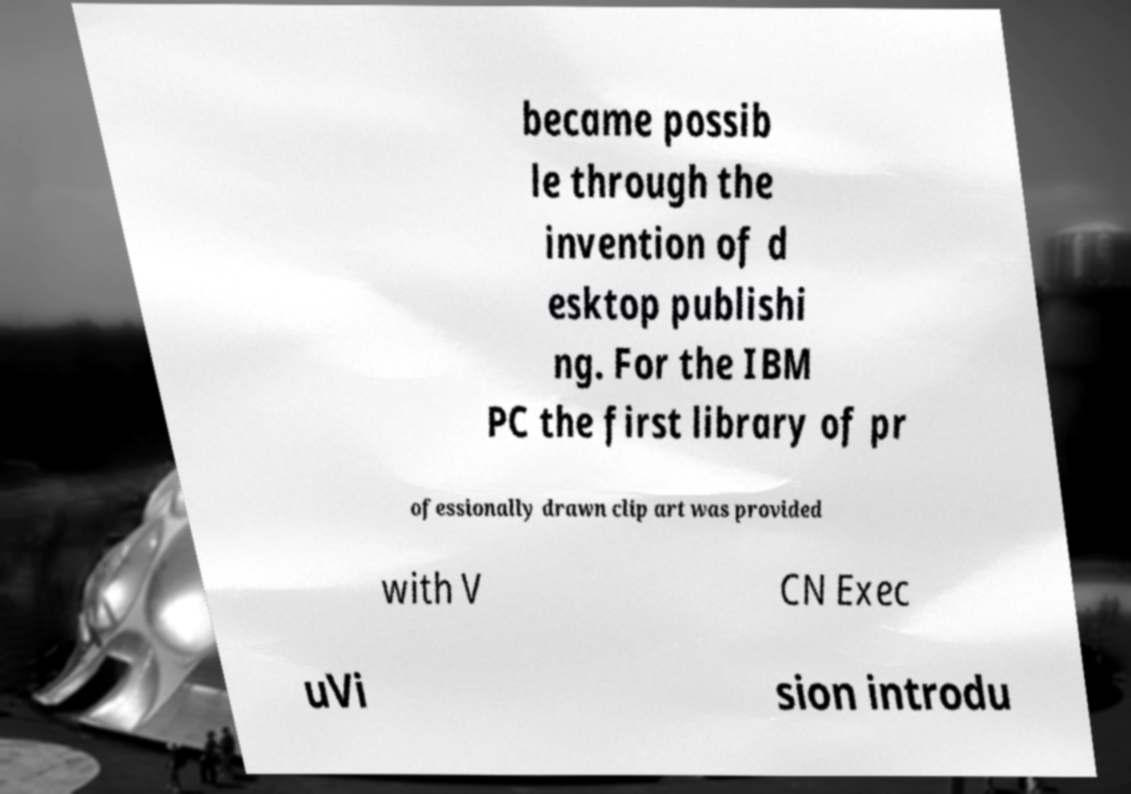For documentation purposes, I need the text within this image transcribed. Could you provide that? became possib le through the invention of d esktop publishi ng. For the IBM PC the first library of pr ofessionally drawn clip art was provided with V CN Exec uVi sion introdu 